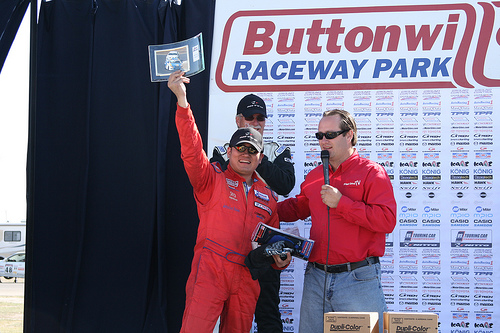<image>
Can you confirm if the board is behind the man? Yes. From this viewpoint, the board is positioned behind the man, with the man partially or fully occluding the board. 